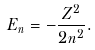<formula> <loc_0><loc_0><loc_500><loc_500>E _ { n } = - { \frac { Z ^ { 2 } } { 2 n ^ { 2 } } } .</formula> 